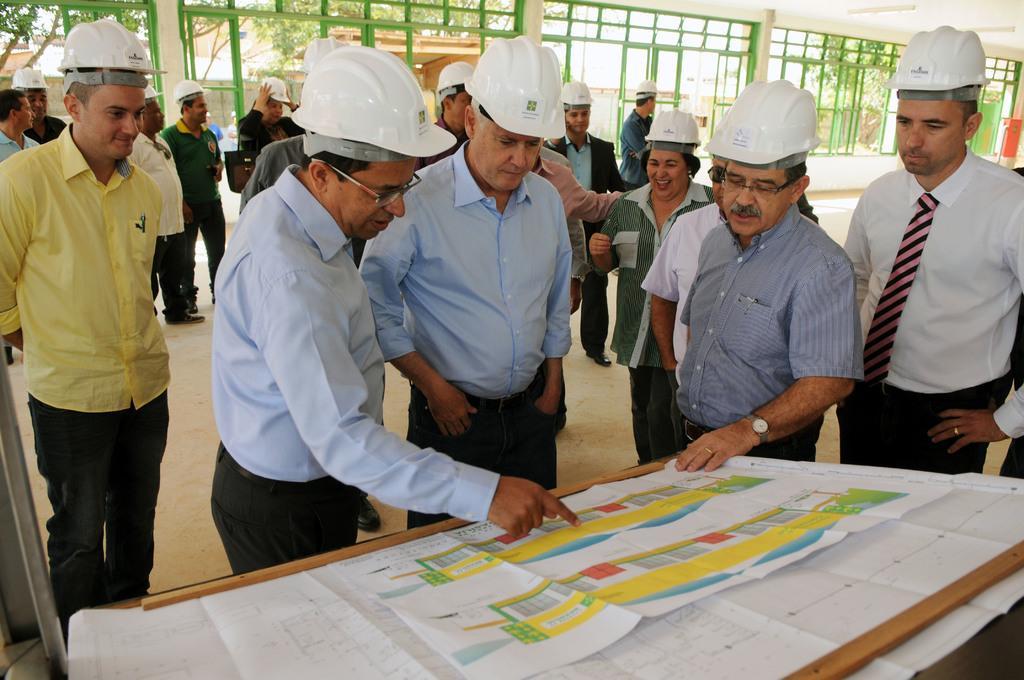Please provide a concise description of this image. In the center of the image there are people standing wearing white color helmet. At the bottom of the image there is a table there is a chart on it. In the background of the image there is a glass door. There are trees. 